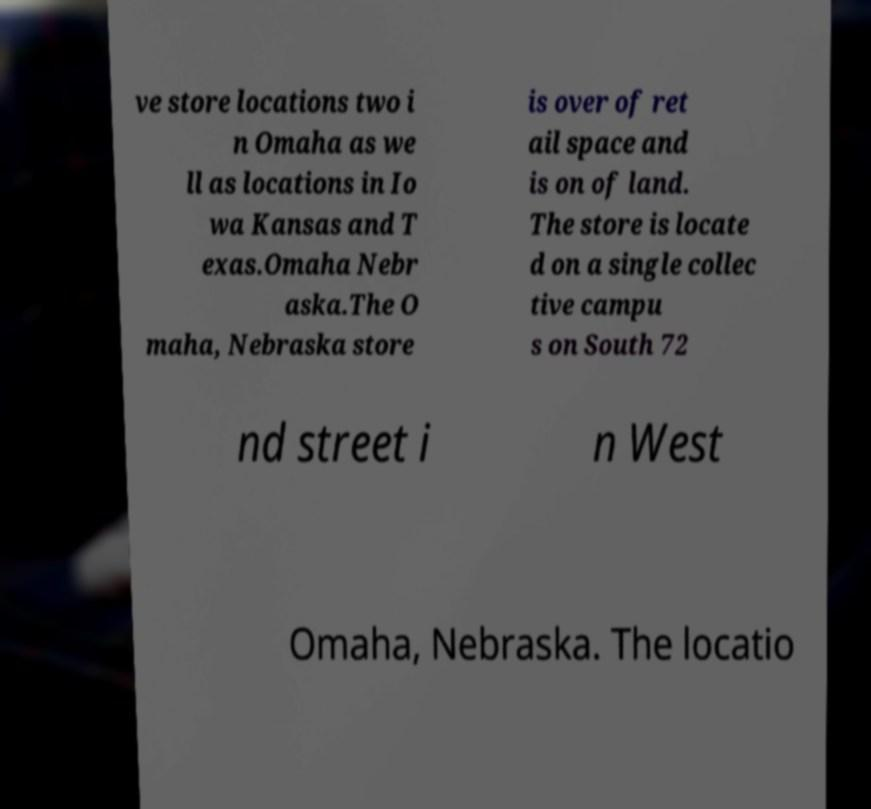Can you accurately transcribe the text from the provided image for me? ve store locations two i n Omaha as we ll as locations in Io wa Kansas and T exas.Omaha Nebr aska.The O maha, Nebraska store is over of ret ail space and is on of land. The store is locate d on a single collec tive campu s on South 72 nd street i n West Omaha, Nebraska. The locatio 